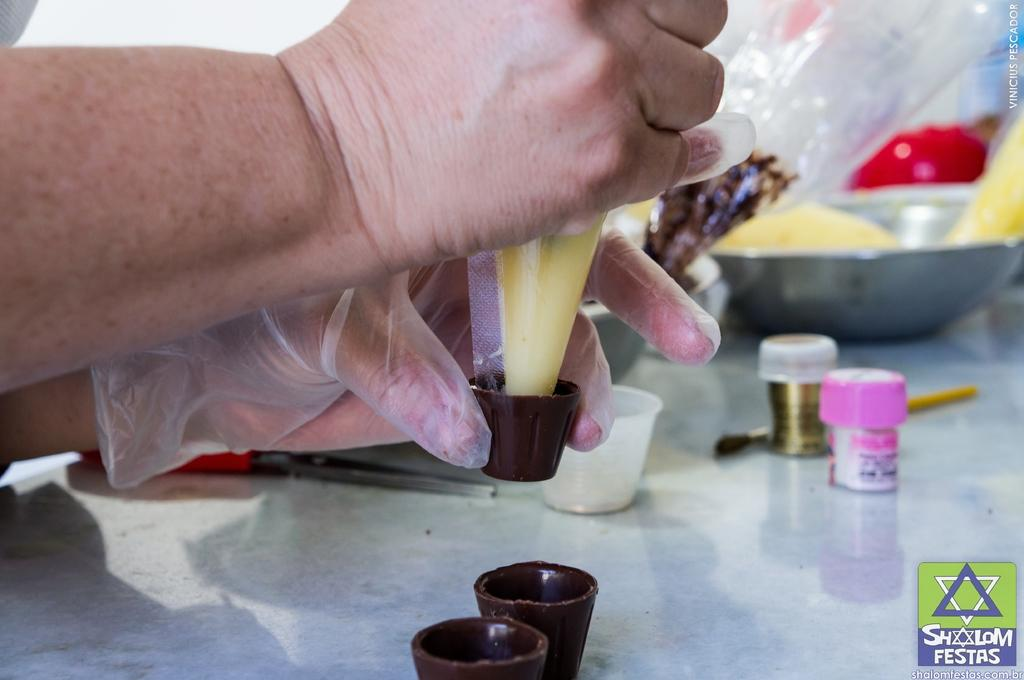What is the person's hand holding in the image? The person's hand is holding small chocolate cups in the image. What is inside the chocolate cups? The chocolate cups have cream in them. What can be seen behind the hand in the image? There is a pink and golden bottle behind the hand. What type of material are the covers visible in the image made of? The covers visible in the image are plastic. What type of cake is being prepared in the image? There is no cake visible or mentioned in the image. What color is the flesh of the person holding the chocolate cups? The image only shows a hand holding chocolate cups, and there is no information about the person's flesh color. 